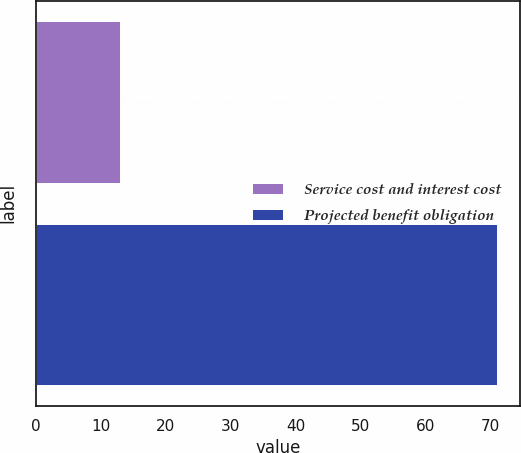<chart> <loc_0><loc_0><loc_500><loc_500><bar_chart><fcel>Service cost and interest cost<fcel>Projected benefit obligation<nl><fcel>13<fcel>71<nl></chart> 